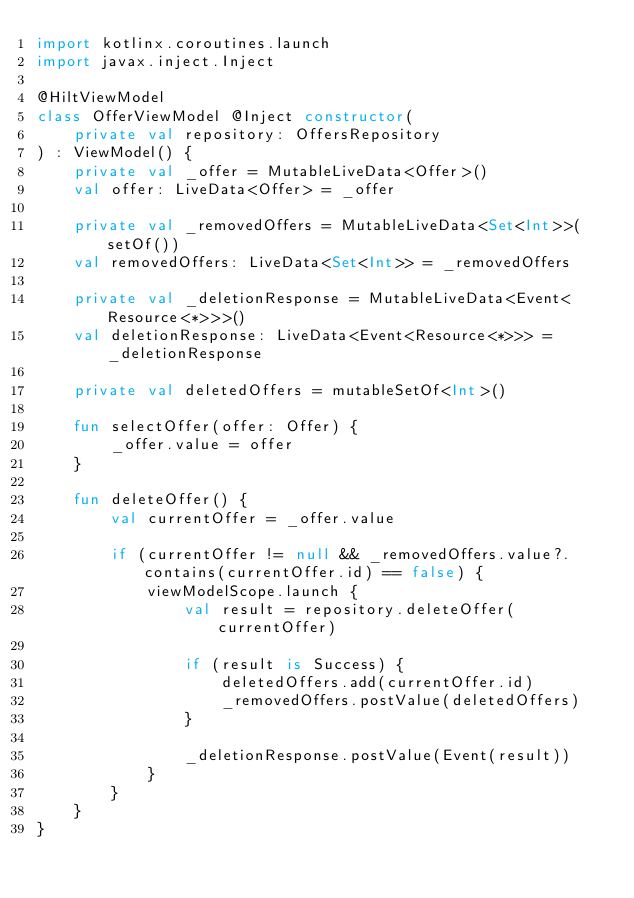Convert code to text. <code><loc_0><loc_0><loc_500><loc_500><_Kotlin_>import kotlinx.coroutines.launch
import javax.inject.Inject

@HiltViewModel
class OfferViewModel @Inject constructor(
    private val repository: OffersRepository
) : ViewModel() {
    private val _offer = MutableLiveData<Offer>()
    val offer: LiveData<Offer> = _offer

    private val _removedOffers = MutableLiveData<Set<Int>>(setOf())
    val removedOffers: LiveData<Set<Int>> = _removedOffers

    private val _deletionResponse = MutableLiveData<Event<Resource<*>>>()
    val deletionResponse: LiveData<Event<Resource<*>>> = _deletionResponse

    private val deletedOffers = mutableSetOf<Int>()

    fun selectOffer(offer: Offer) {
        _offer.value = offer
    }

    fun deleteOffer() {
        val currentOffer = _offer.value

        if (currentOffer != null && _removedOffers.value?.contains(currentOffer.id) == false) {
            viewModelScope.launch {
                val result = repository.deleteOffer(currentOffer)

                if (result is Success) {
                    deletedOffers.add(currentOffer.id)
                    _removedOffers.postValue(deletedOffers)
                }

                _deletionResponse.postValue(Event(result))
            }
        }
    }
}</code> 